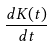<formula> <loc_0><loc_0><loc_500><loc_500>\frac { d K ( t ) } { d t }</formula> 